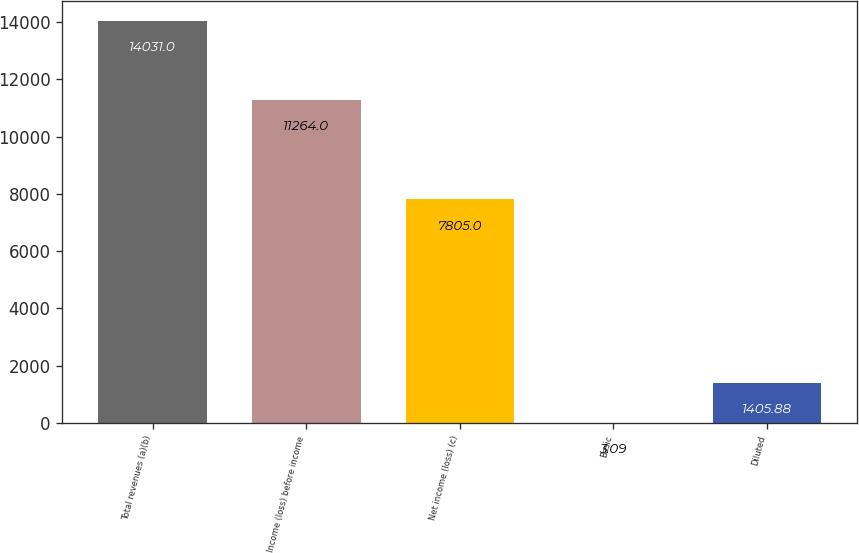<chart> <loc_0><loc_0><loc_500><loc_500><bar_chart><fcel>Total revenues (a)(b)<fcel>Income (loss) before income<fcel>Net income (loss) (c)<fcel>Basic<fcel>Diluted<nl><fcel>14031<fcel>11264<fcel>7805<fcel>3.09<fcel>1405.88<nl></chart> 